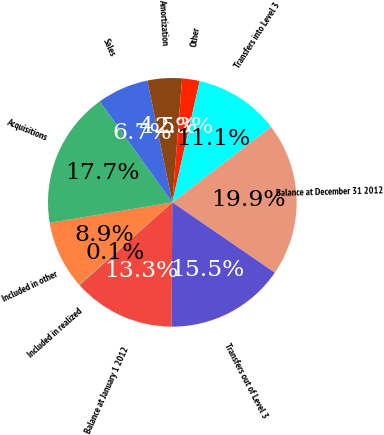<chart> <loc_0><loc_0><loc_500><loc_500><pie_chart><fcel>Balance at January 1 2012<fcel>Included in realized<fcel>Included in other<fcel>Acquisitions<fcel>Sales<fcel>Amortization<fcel>Other<fcel>Transfers into Level 3<fcel>Balance at December 31 2012<fcel>Transfers out of Level 3<nl><fcel>13.31%<fcel>0.06%<fcel>8.9%<fcel>17.73%<fcel>6.69%<fcel>4.48%<fcel>2.27%<fcel>11.1%<fcel>19.94%<fcel>15.52%<nl></chart> 